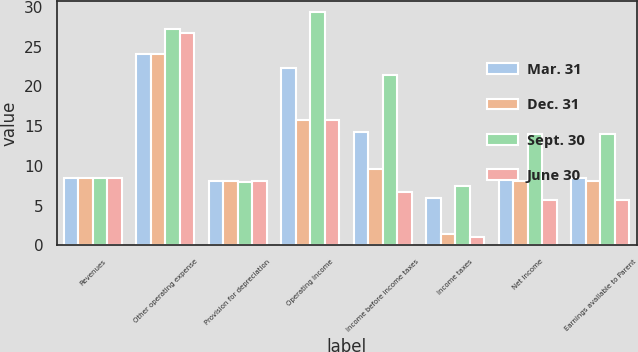Convert chart to OTSL. <chart><loc_0><loc_0><loc_500><loc_500><stacked_bar_chart><ecel><fcel>Revenues<fcel>Other operating expense<fcel>Provision for depreciation<fcel>Operating Income<fcel>Income before income taxes<fcel>Income taxes<fcel>Net Income<fcel>Earnings available to Parent<nl><fcel>Mar. 31<fcel>8.4<fcel>24<fcel>8.1<fcel>22.3<fcel>14.3<fcel>5.9<fcel>8.4<fcel>8.4<nl><fcel>Dec. 31<fcel>8.4<fcel>24<fcel>8.1<fcel>15.8<fcel>9.6<fcel>1.4<fcel>8.1<fcel>8.1<nl><fcel>Sept. 30<fcel>8.4<fcel>27.2<fcel>7.9<fcel>29.3<fcel>21.4<fcel>7.4<fcel>14<fcel>14<nl><fcel>June 30<fcel>8.4<fcel>26.7<fcel>8.1<fcel>15.7<fcel>6.7<fcel>1<fcel>5.7<fcel>5.7<nl></chart> 